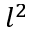<formula> <loc_0><loc_0><loc_500><loc_500>l ^ { 2 }</formula> 